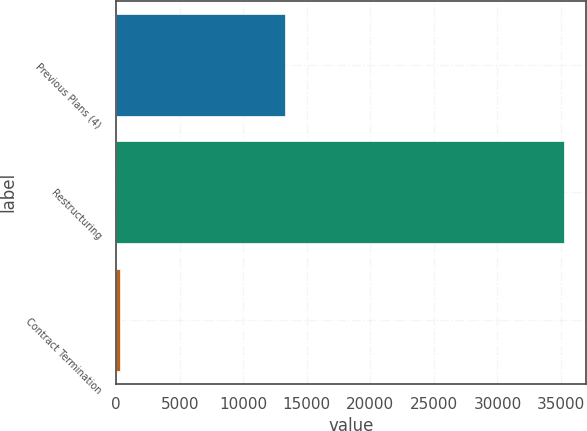Convert chart. <chart><loc_0><loc_0><loc_500><loc_500><bar_chart><fcel>Previous Plans (4)<fcel>Restructuring<fcel>Contract Termination<nl><fcel>13299<fcel>35235<fcel>300<nl></chart> 